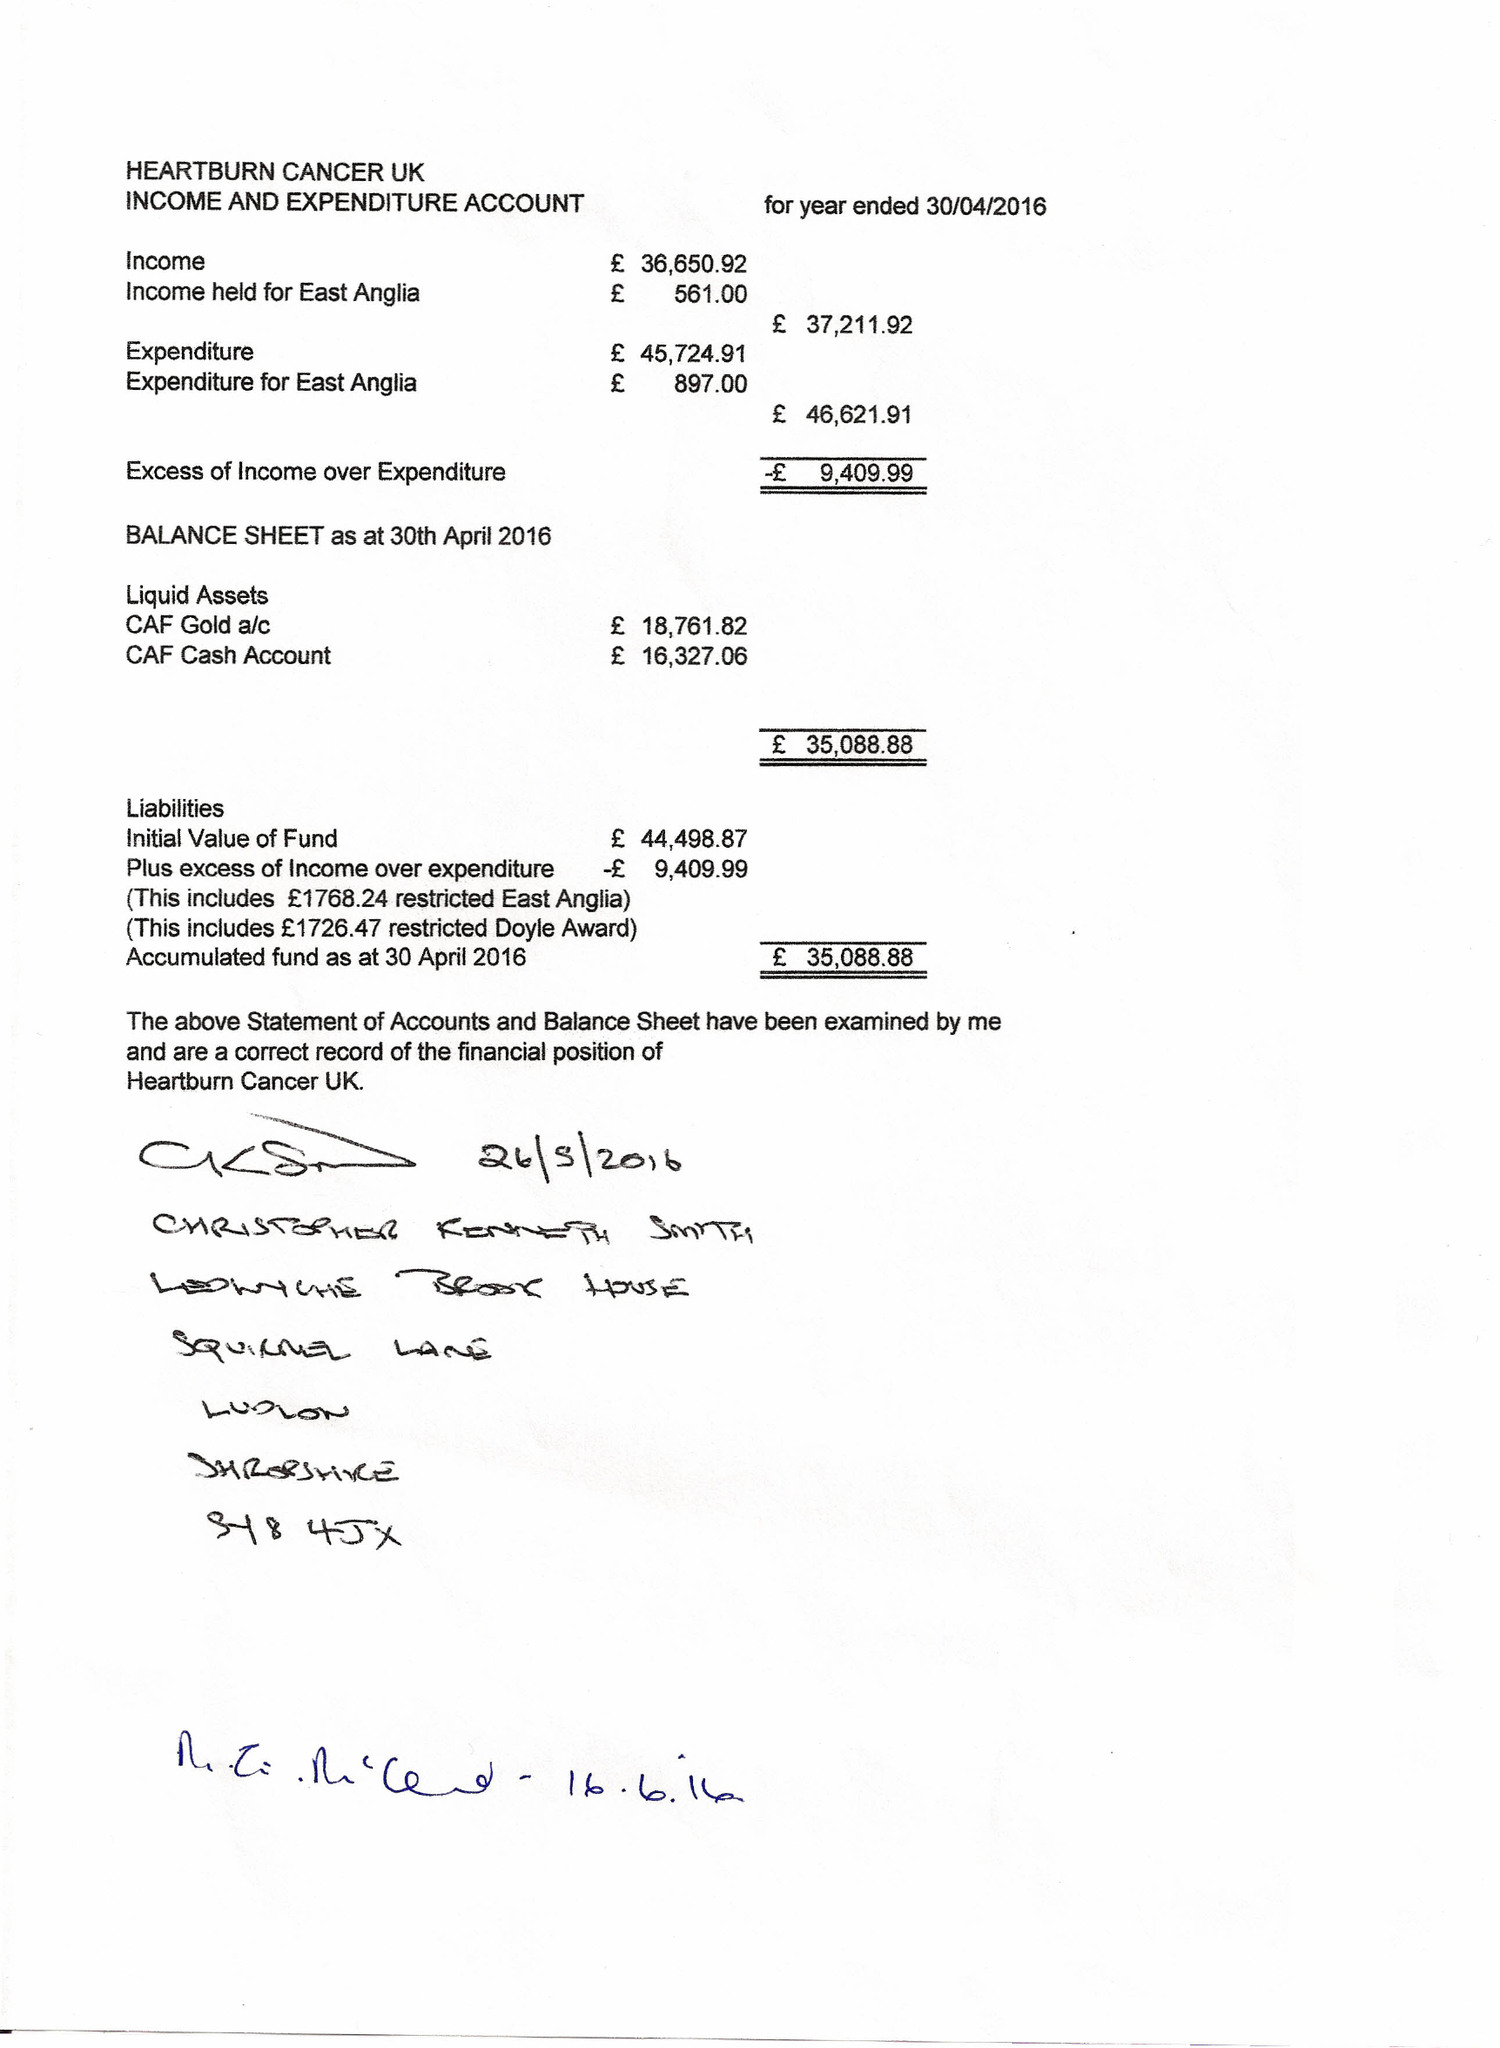What is the value for the charity_number?
Answer the question using a single word or phrase. 1136413 